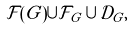<formula> <loc_0><loc_0><loc_500><loc_500>\mathcal { F } ( G ) \cup \mathcal { F } _ { G } \cup \mathcal { D } _ { G } ,</formula> 